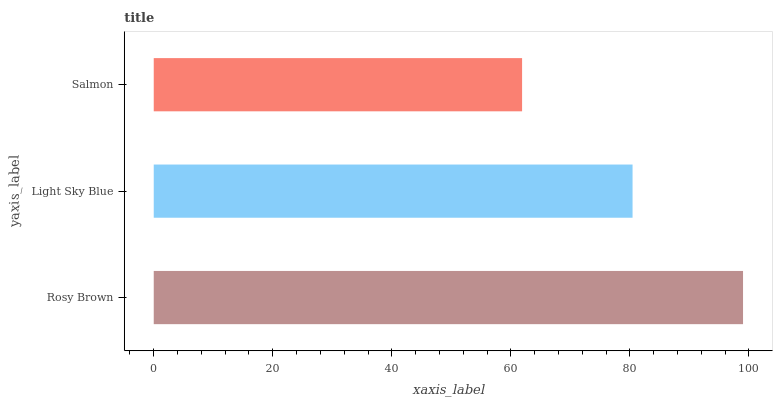Is Salmon the minimum?
Answer yes or no. Yes. Is Rosy Brown the maximum?
Answer yes or no. Yes. Is Light Sky Blue the minimum?
Answer yes or no. No. Is Light Sky Blue the maximum?
Answer yes or no. No. Is Rosy Brown greater than Light Sky Blue?
Answer yes or no. Yes. Is Light Sky Blue less than Rosy Brown?
Answer yes or no. Yes. Is Light Sky Blue greater than Rosy Brown?
Answer yes or no. No. Is Rosy Brown less than Light Sky Blue?
Answer yes or no. No. Is Light Sky Blue the high median?
Answer yes or no. Yes. Is Light Sky Blue the low median?
Answer yes or no. Yes. Is Salmon the high median?
Answer yes or no. No. Is Salmon the low median?
Answer yes or no. No. 